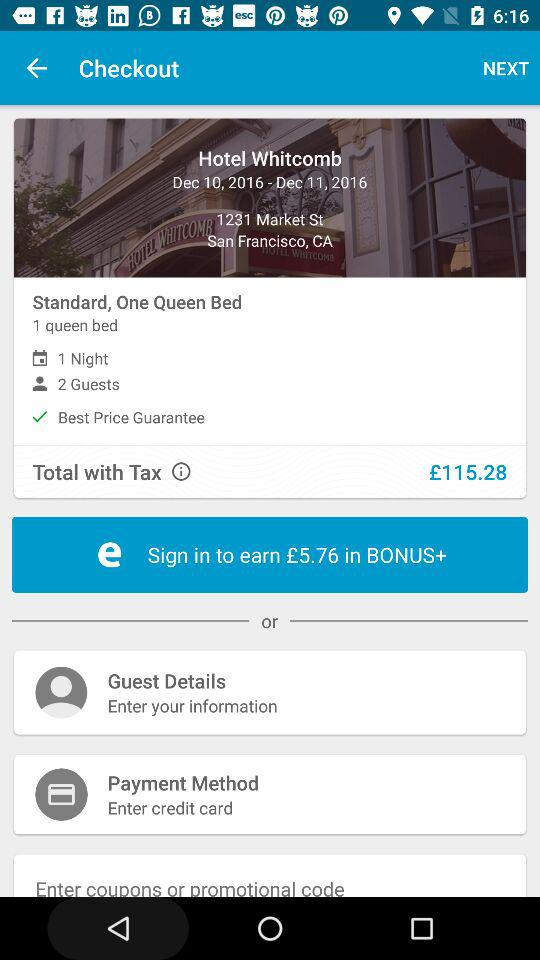What is the actual price of the "Hotel Kabuki - a Joie de..."? The price of the hotel Kabuki is £146. 